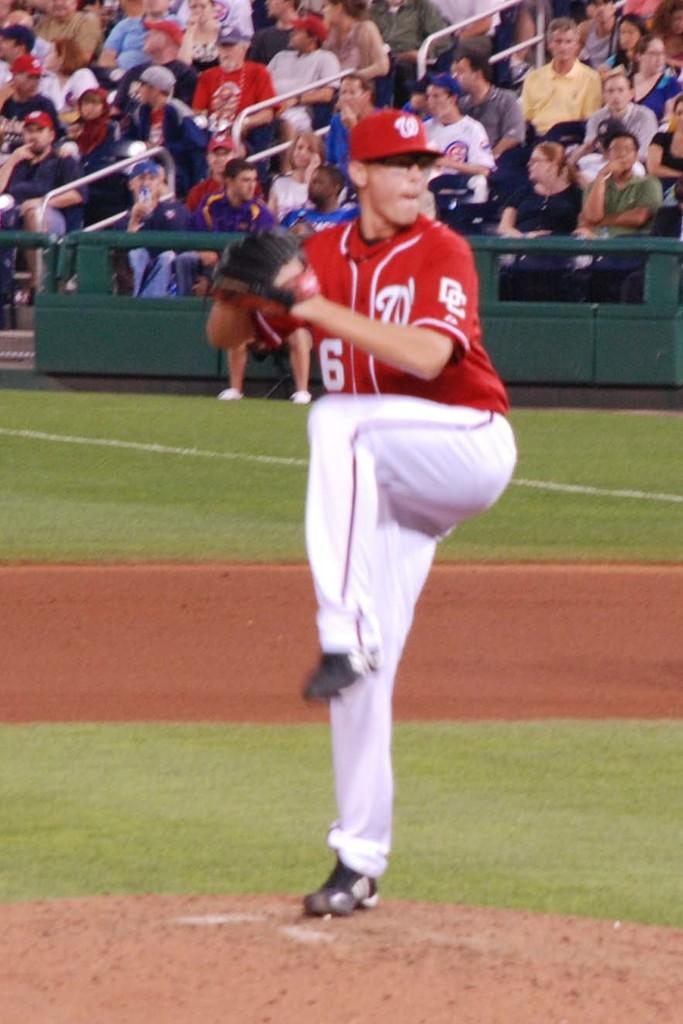What is the player number of this thrower?
Provide a succinct answer. 6. What initials are written on player arm of shirt?
Provide a short and direct response. Dc. 